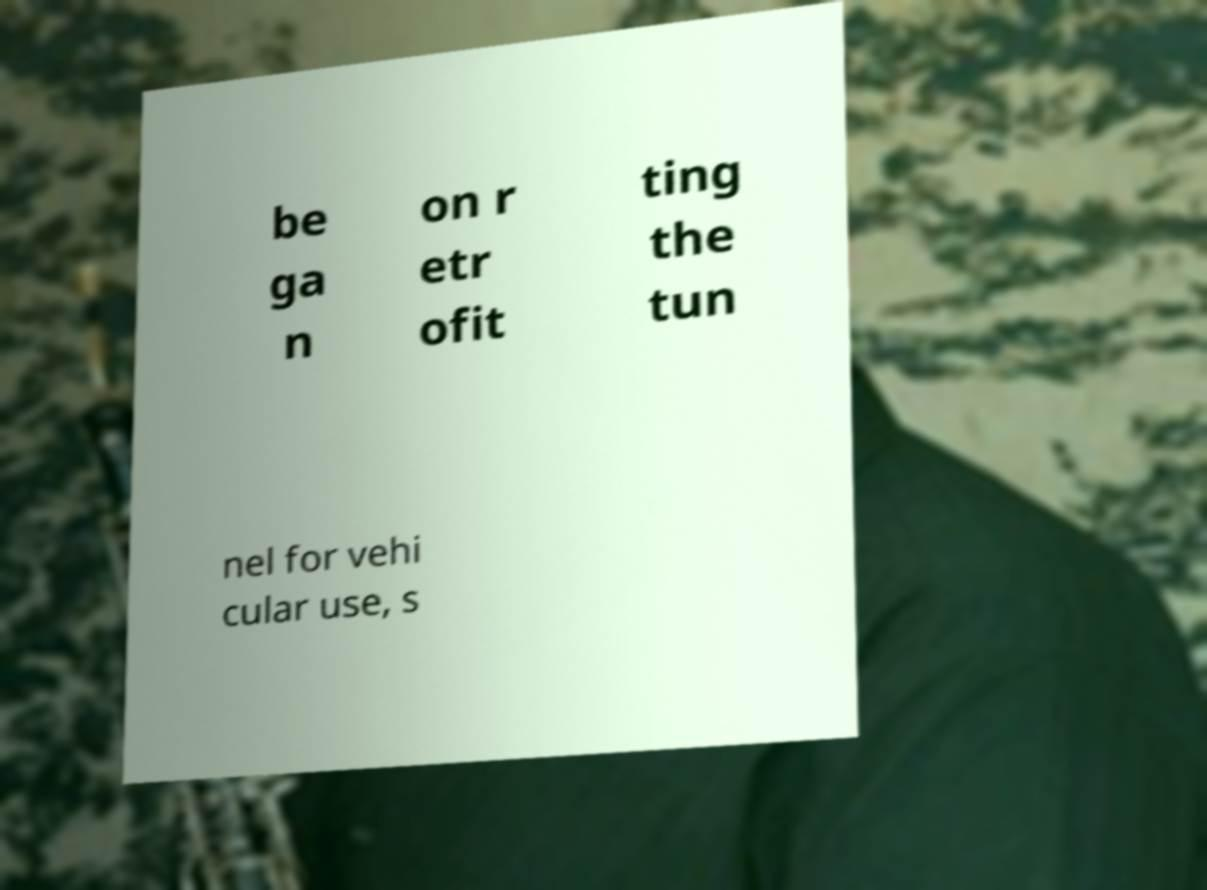What messages or text are displayed in this image? I need them in a readable, typed format. be ga n on r etr ofit ting the tun nel for vehi cular use, s 